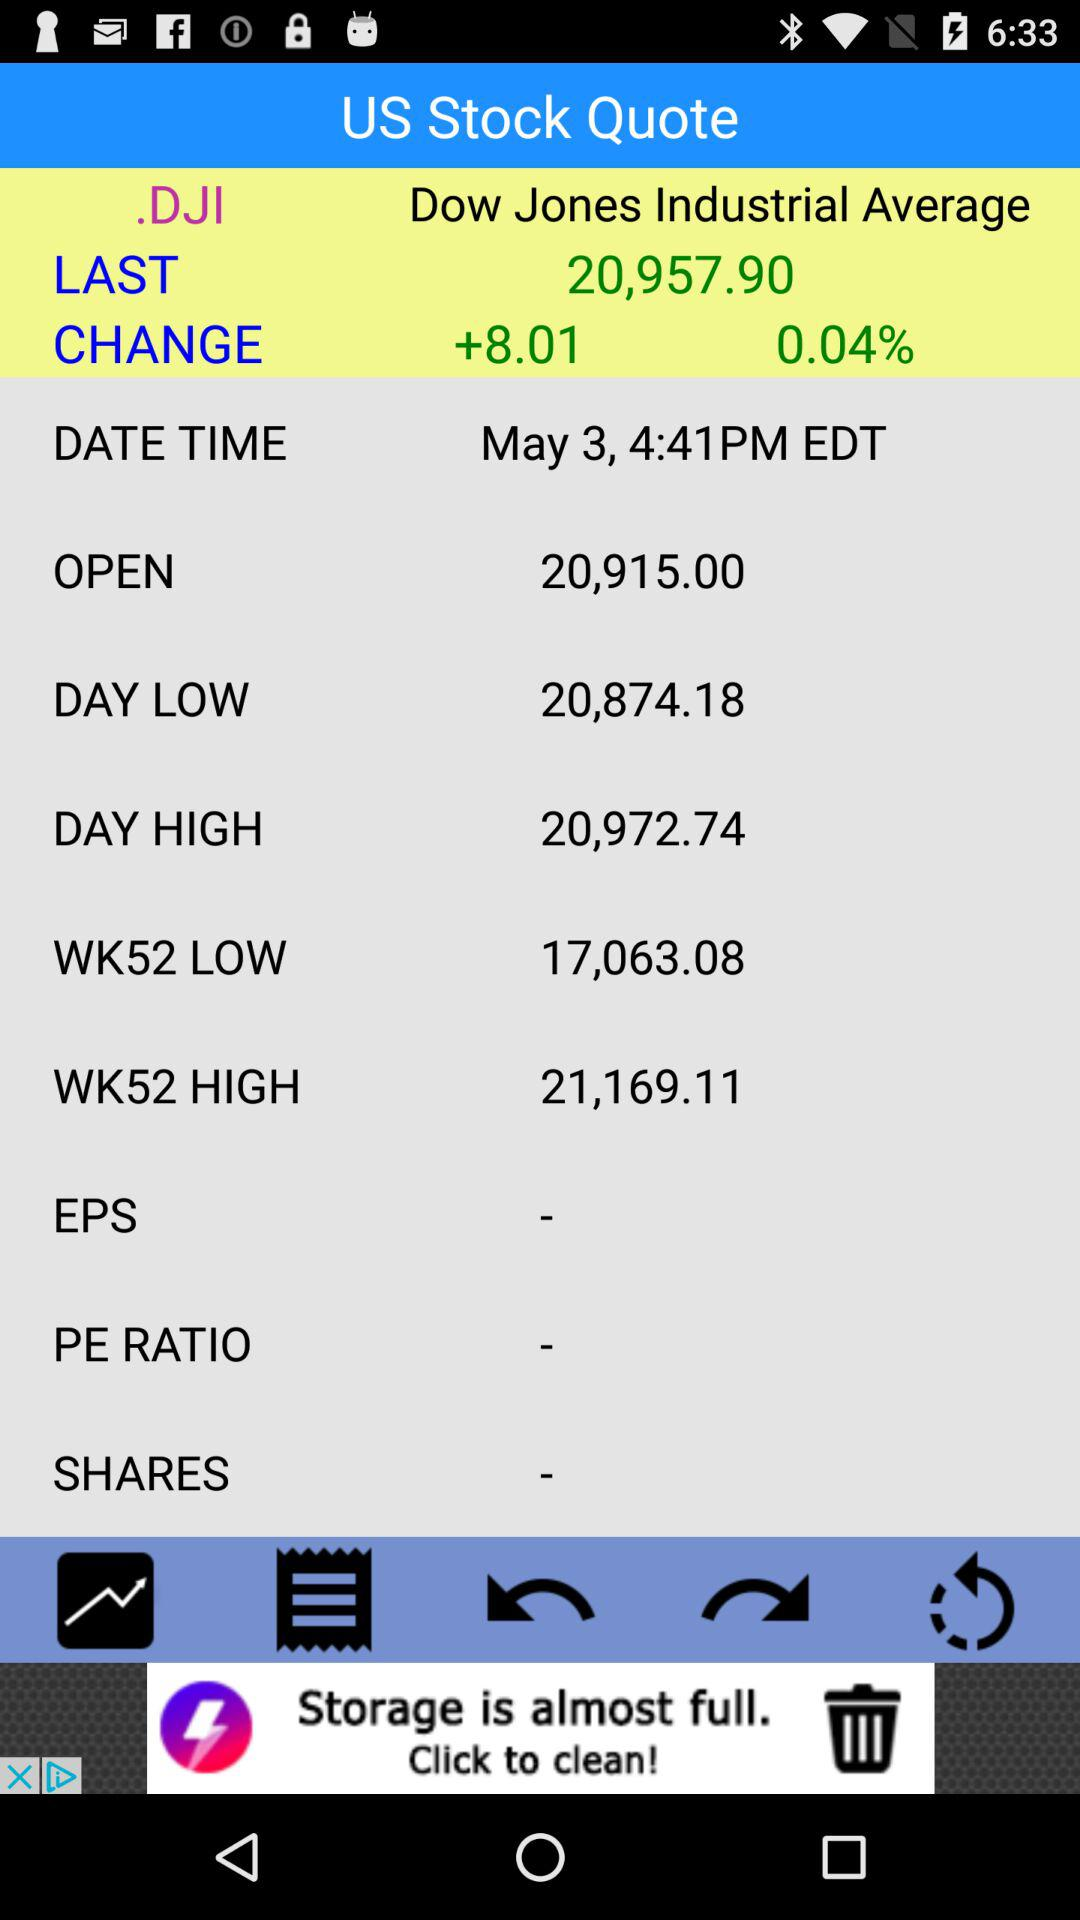What is the time for.DJI stock? The time is 4:41 p.m. EDT. 